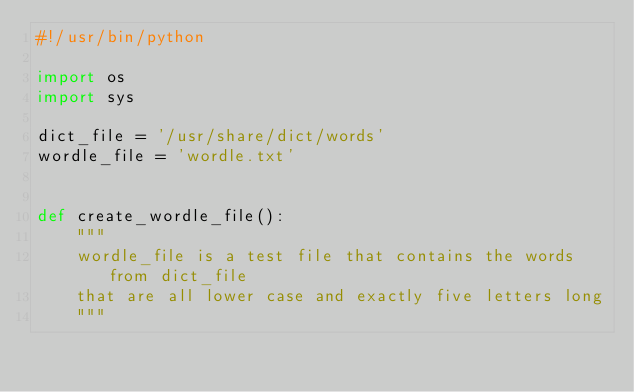Convert code to text. <code><loc_0><loc_0><loc_500><loc_500><_Python_>#!/usr/bin/python

import os
import sys

dict_file = '/usr/share/dict/words'
wordle_file = 'wordle.txt'


def create_wordle_file():
    """
    wordle_file is a test file that contains the words from dict_file
    that are all lower case and exactly five letters long
    """</code> 